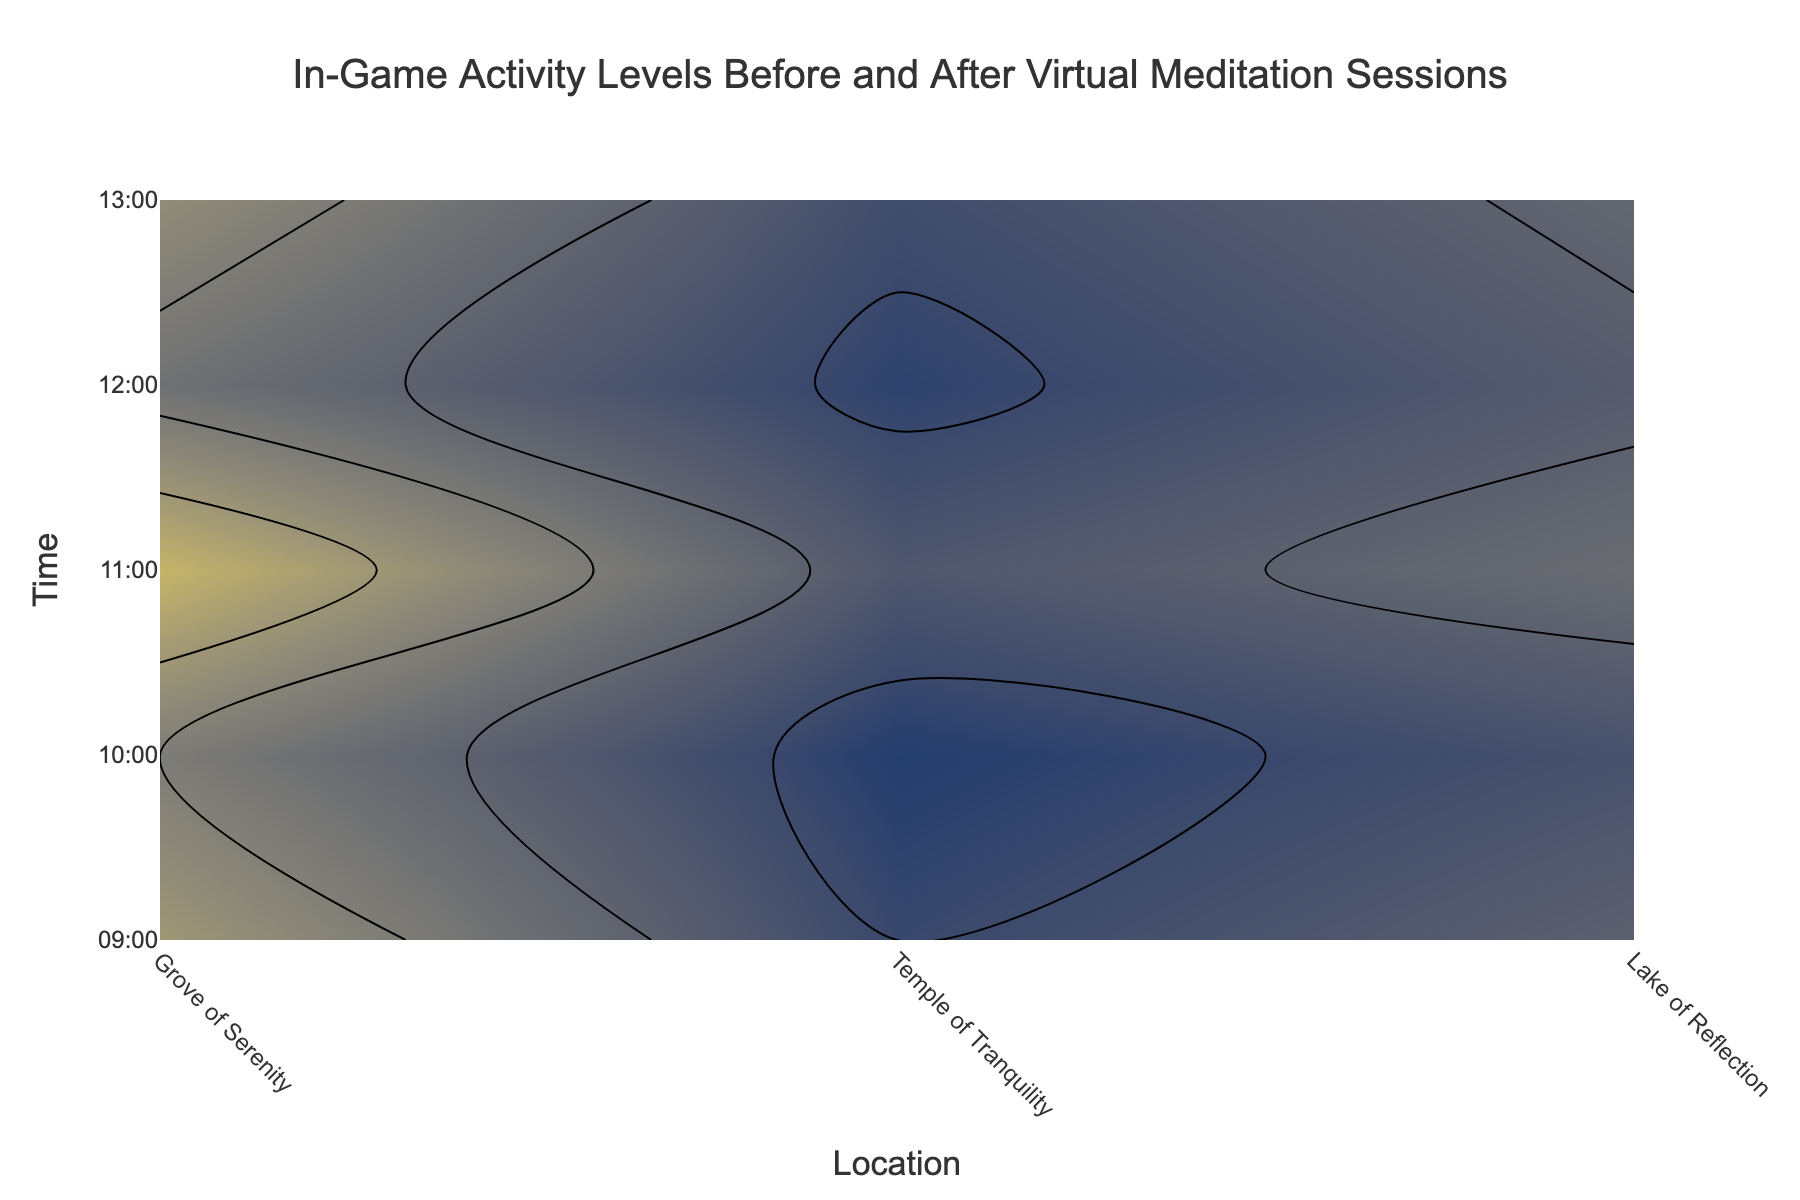What is the title of the figure? The title is located at the top center of the plot and is typically used to describe what the figure represents.
Answer: In-Game Activity Levels Before and After Virtual Meditation Sessions Which location has the highest activity level before meditation at 11:00? By checking the contour lines at 11:00 for all locations, we see that the Grove of Serenity has the highest activity levels.
Answer: Grove of Serenity How does the activity level before meditation compare to after meditation at Temple of Tranquility at 09:00? By comparing the contour lines at Temple of Tranquility at 09:00, the activity level drops from 60 before meditation to 25 after meditation.
Answer: It decreases What is the range of activity levels represented for the 'After Meditation' heatmap? By examining the "After Meditation" contour plot, we see the coloring ranges from 15 to 45 on the color scale.
Answer: 15 to 45 What time has the lowest activity level after meditation at Lake of Reflection? Observing the contour lines for Lake of Reflection across different times, it is lowest at 10:00.
Answer: 10:00 Which location shows the greatest reduction in activity levels from before to after meditation at 13:00? Comparing the before and after activity levels at 13:00, Lake of Reflection drops from 53 to 21, which is the greatest reduction.
Answer: Lake of Reflection Between Grove of Serenity and Temple of Tranquility, which has a higher activity level before meditation at 12:00? By analyzing the contour levels at 12:00, the Grove of Serenity has higher activity levels before meditation compared to the Temple of Tranquility.
Answer: Grove of Serenity What is the overall trend in activity levels after meditation across all locations from 09:00 to 13:00? By observing the "After Meditation" contour across the time axis, we see a general decreasing trend in activity levels as time progresses.
Answer: Decreasing trend 